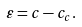<formula> <loc_0><loc_0><loc_500><loc_500>\varepsilon = c - c _ { c } .</formula> 